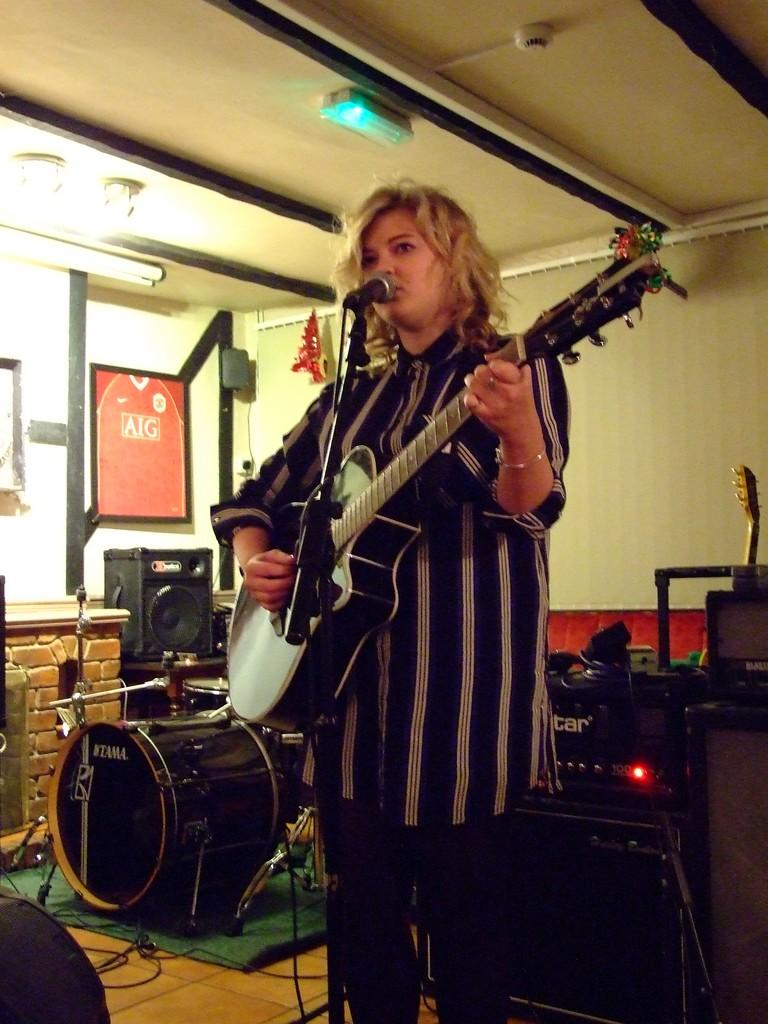Who is present in the image? There is a woman in the image. What is the woman holding in the image? The woman is holding a guitar. What musical instruments can be seen in the background of the image? There is a drum set and a speaker in the background of the image. What type of animals can be seen in the background of the image? There are no animals visible in the image; it features a woman holding a guitar and a drum set and speaker in the background. 